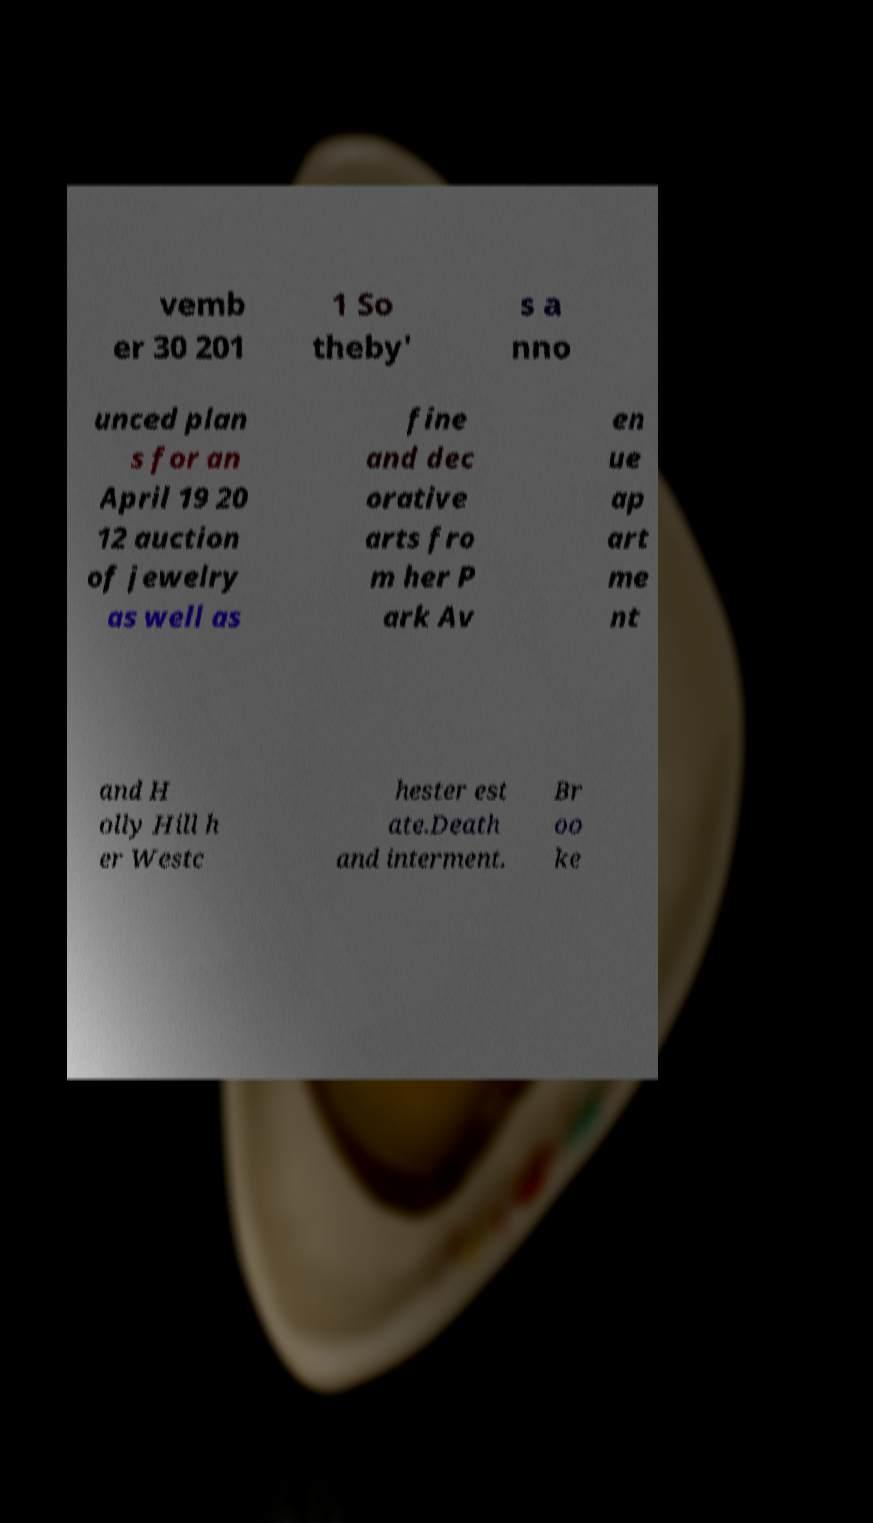What messages or text are displayed in this image? I need them in a readable, typed format. vemb er 30 201 1 So theby' s a nno unced plan s for an April 19 20 12 auction of jewelry as well as fine and dec orative arts fro m her P ark Av en ue ap art me nt and H olly Hill h er Westc hester est ate.Death and interment. Br oo ke 